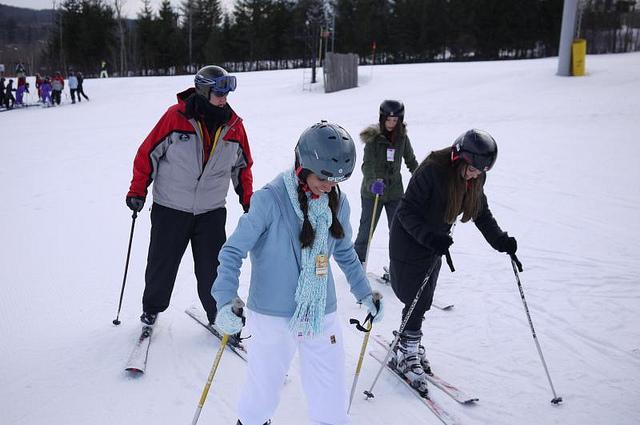What kind of hairstyle does the girl in light blue have?
Concise answer only. Braids. Are they skiing?
Keep it brief. Yes. How many women are in the image?
Be succinct. 4. What is over the mouth of the person on the left?
Write a very short answer. Scarf. How many poles are there?
Answer briefly. 6. 